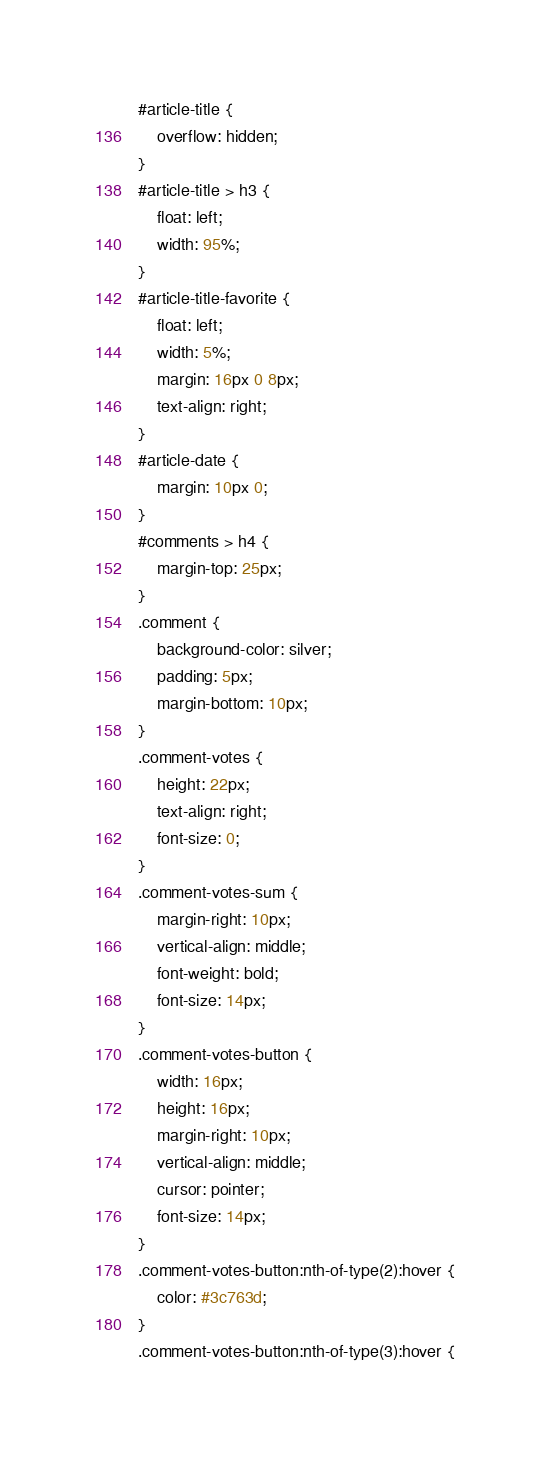<code> <loc_0><loc_0><loc_500><loc_500><_CSS_>#article-title {
    overflow: hidden;
}
#article-title > h3 {
    float: left;
    width: 95%;
}
#article-title-favorite {
    float: left;
    width: 5%;
    margin: 16px 0 8px;
    text-align: right;
}
#article-date {
    margin: 10px 0;
}
#comments > h4 {
    margin-top: 25px;
}
.comment {
    background-color: silver;
    padding: 5px;
    margin-bottom: 10px;
}
.comment-votes {
    height: 22px;
    text-align: right;
    font-size: 0;
}
.comment-votes-sum {
    margin-right: 10px;
    vertical-align: middle;
    font-weight: bold;
    font-size: 14px;
}
.comment-votes-button {
    width: 16px;
    height: 16px;
    margin-right: 10px;
    vertical-align: middle;
    cursor: pointer;
    font-size: 14px;
}
.comment-votes-button:nth-of-type(2):hover {
    color: #3c763d;
}
.comment-votes-button:nth-of-type(3):hover {</code> 